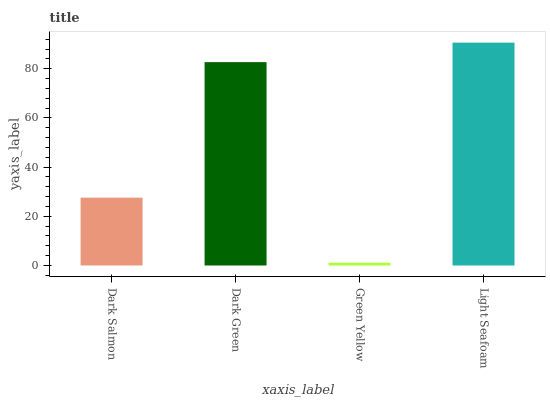Is Green Yellow the minimum?
Answer yes or no. Yes. Is Light Seafoam the maximum?
Answer yes or no. Yes. Is Dark Green the minimum?
Answer yes or no. No. Is Dark Green the maximum?
Answer yes or no. No. Is Dark Green greater than Dark Salmon?
Answer yes or no. Yes. Is Dark Salmon less than Dark Green?
Answer yes or no. Yes. Is Dark Salmon greater than Dark Green?
Answer yes or no. No. Is Dark Green less than Dark Salmon?
Answer yes or no. No. Is Dark Green the high median?
Answer yes or no. Yes. Is Dark Salmon the low median?
Answer yes or no. Yes. Is Dark Salmon the high median?
Answer yes or no. No. Is Dark Green the low median?
Answer yes or no. No. 